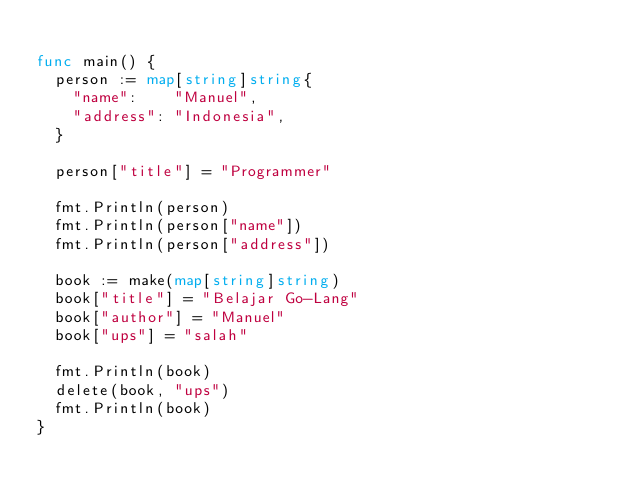Convert code to text. <code><loc_0><loc_0><loc_500><loc_500><_Go_>
func main() {
	person := map[string]string{
		"name":    "Manuel",
		"address": "Indonesia",
	}

	person["title"] = "Programmer"

	fmt.Println(person)
	fmt.Println(person["name"])
	fmt.Println(person["address"])

	book := make(map[string]string)
	book["title"] = "Belajar Go-Lang"
	book["author"] = "Manuel"
	book["ups"] = "salah"

	fmt.Println(book)
	delete(book, "ups")
	fmt.Println(book)
}</code> 